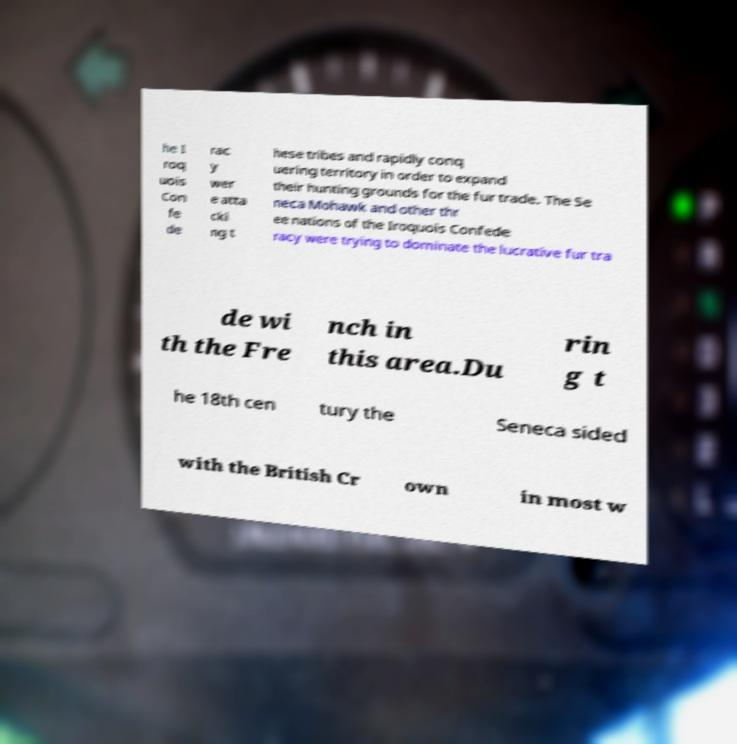Please identify and transcribe the text found in this image. he I roq uois Con fe de rac y wer e atta cki ng t hese tribes and rapidly conq uering territory in order to expand their hunting grounds for the fur trade. The Se neca Mohawk and other thr ee nations of the Iroquois Confede racy were trying to dominate the lucrative fur tra de wi th the Fre nch in this area.Du rin g t he 18th cen tury the Seneca sided with the British Cr own in most w 